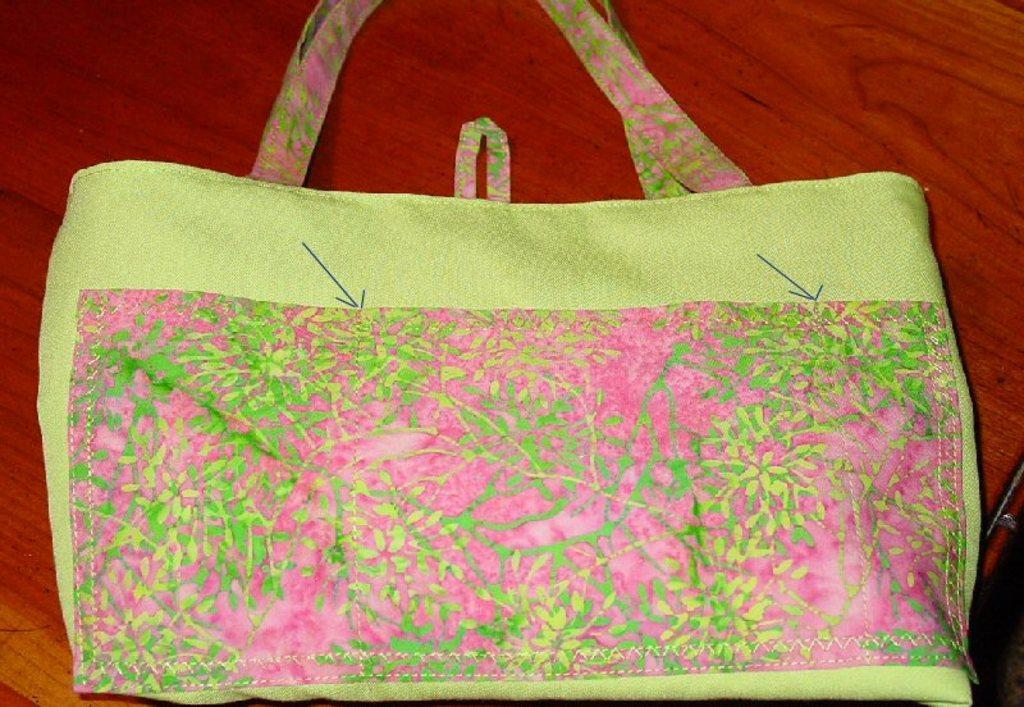Please provide a concise description of this image. There is a green handbag placed on a white table. 